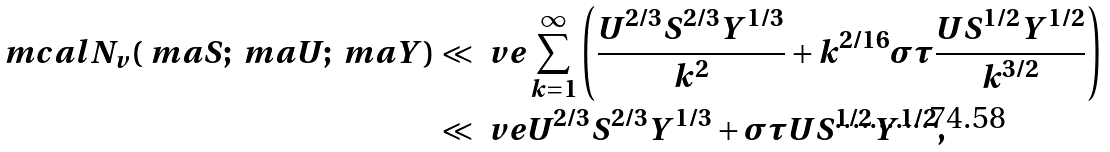<formula> <loc_0><loc_0><loc_500><loc_500>\ m c a l { N } _ { v } ( \ m a { S } ; \ m a { U } ; \ m a { Y } ) & \ll _ { \ } v e \sum _ { k = 1 } ^ { \infty } \left ( \frac { U ^ { 2 / 3 } S ^ { 2 / 3 } Y ^ { 1 / 3 } } { k ^ { 2 } } + k ^ { 2 / 1 6 } \sigma \tau \frac { U S ^ { 1 / 2 } Y ^ { 1 / 2 } } { k ^ { 3 / 2 } } \right ) \\ & \ll _ { \ } v e U ^ { 2 / 3 } S ^ { 2 / 3 } Y ^ { 1 / 3 } + \sigma \tau U S ^ { 1 / 2 } Y ^ { 1 / 2 } ,</formula> 